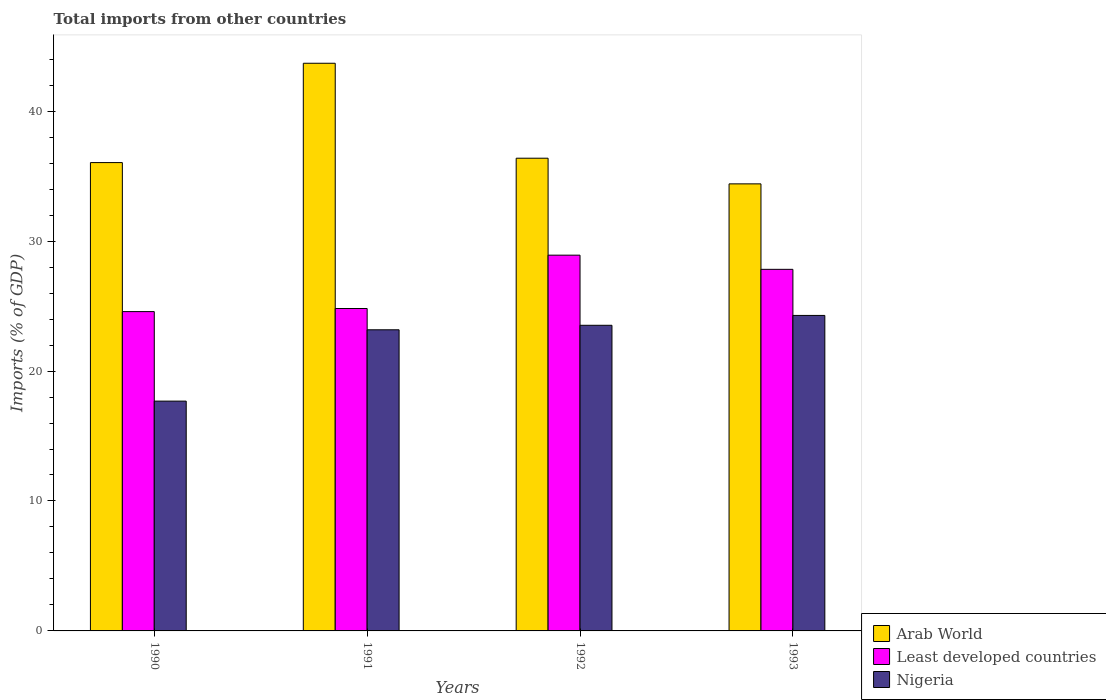How many groups of bars are there?
Offer a very short reply. 4. Are the number of bars on each tick of the X-axis equal?
Keep it short and to the point. Yes. What is the label of the 1st group of bars from the left?
Your answer should be compact. 1990. In how many cases, is the number of bars for a given year not equal to the number of legend labels?
Offer a terse response. 0. What is the total imports in Nigeria in 1993?
Your answer should be compact. 24.28. Across all years, what is the maximum total imports in Nigeria?
Make the answer very short. 24.28. Across all years, what is the minimum total imports in Least developed countries?
Your response must be concise. 24.57. In which year was the total imports in Nigeria maximum?
Give a very brief answer. 1993. What is the total total imports in Nigeria in the graph?
Provide a succinct answer. 88.66. What is the difference between the total imports in Arab World in 1991 and that in 1993?
Your response must be concise. 9.28. What is the difference between the total imports in Least developed countries in 1992 and the total imports in Arab World in 1991?
Your answer should be compact. -14.77. What is the average total imports in Arab World per year?
Give a very brief answer. 37.63. In the year 1990, what is the difference between the total imports in Arab World and total imports in Least developed countries?
Your response must be concise. 11.47. What is the ratio of the total imports in Arab World in 1991 to that in 1993?
Ensure brevity in your answer.  1.27. Is the difference between the total imports in Arab World in 1991 and 1992 greater than the difference between the total imports in Least developed countries in 1991 and 1992?
Give a very brief answer. Yes. What is the difference between the highest and the second highest total imports in Nigeria?
Provide a succinct answer. 0.76. What is the difference between the highest and the lowest total imports in Nigeria?
Offer a terse response. 6.59. What does the 1st bar from the left in 1991 represents?
Give a very brief answer. Arab World. What does the 1st bar from the right in 1990 represents?
Keep it short and to the point. Nigeria. Is it the case that in every year, the sum of the total imports in Least developed countries and total imports in Arab World is greater than the total imports in Nigeria?
Make the answer very short. Yes. How many bars are there?
Keep it short and to the point. 12. Are the values on the major ticks of Y-axis written in scientific E-notation?
Make the answer very short. No. Does the graph contain grids?
Keep it short and to the point. No. Where does the legend appear in the graph?
Offer a terse response. Bottom right. How many legend labels are there?
Offer a very short reply. 3. What is the title of the graph?
Your answer should be very brief. Total imports from other countries. Does "Uzbekistan" appear as one of the legend labels in the graph?
Give a very brief answer. No. What is the label or title of the Y-axis?
Your response must be concise. Imports (% of GDP). What is the Imports (% of GDP) in Arab World in 1990?
Your answer should be very brief. 36.04. What is the Imports (% of GDP) of Least developed countries in 1990?
Offer a terse response. 24.57. What is the Imports (% of GDP) of Nigeria in 1990?
Make the answer very short. 17.69. What is the Imports (% of GDP) of Arab World in 1991?
Provide a short and direct response. 43.69. What is the Imports (% of GDP) of Least developed countries in 1991?
Provide a succinct answer. 24.81. What is the Imports (% of GDP) in Nigeria in 1991?
Your response must be concise. 23.18. What is the Imports (% of GDP) of Arab World in 1992?
Give a very brief answer. 36.38. What is the Imports (% of GDP) in Least developed countries in 1992?
Keep it short and to the point. 28.92. What is the Imports (% of GDP) of Nigeria in 1992?
Provide a short and direct response. 23.52. What is the Imports (% of GDP) of Arab World in 1993?
Make the answer very short. 34.41. What is the Imports (% of GDP) of Least developed countries in 1993?
Make the answer very short. 27.83. What is the Imports (% of GDP) in Nigeria in 1993?
Keep it short and to the point. 24.28. Across all years, what is the maximum Imports (% of GDP) of Arab World?
Provide a succinct answer. 43.69. Across all years, what is the maximum Imports (% of GDP) of Least developed countries?
Offer a terse response. 28.92. Across all years, what is the maximum Imports (% of GDP) of Nigeria?
Your response must be concise. 24.28. Across all years, what is the minimum Imports (% of GDP) in Arab World?
Provide a succinct answer. 34.41. Across all years, what is the minimum Imports (% of GDP) of Least developed countries?
Your answer should be very brief. 24.57. Across all years, what is the minimum Imports (% of GDP) in Nigeria?
Your answer should be very brief. 17.69. What is the total Imports (% of GDP) in Arab World in the graph?
Your answer should be compact. 150.52. What is the total Imports (% of GDP) in Least developed countries in the graph?
Provide a succinct answer. 106.13. What is the total Imports (% of GDP) of Nigeria in the graph?
Offer a terse response. 88.66. What is the difference between the Imports (% of GDP) of Arab World in 1990 and that in 1991?
Make the answer very short. -7.64. What is the difference between the Imports (% of GDP) in Least developed countries in 1990 and that in 1991?
Keep it short and to the point. -0.24. What is the difference between the Imports (% of GDP) of Nigeria in 1990 and that in 1991?
Offer a terse response. -5.49. What is the difference between the Imports (% of GDP) of Arab World in 1990 and that in 1992?
Provide a short and direct response. -0.34. What is the difference between the Imports (% of GDP) in Least developed countries in 1990 and that in 1992?
Your answer should be very brief. -4.34. What is the difference between the Imports (% of GDP) in Nigeria in 1990 and that in 1992?
Make the answer very short. -5.84. What is the difference between the Imports (% of GDP) in Arab World in 1990 and that in 1993?
Make the answer very short. 1.64. What is the difference between the Imports (% of GDP) of Least developed countries in 1990 and that in 1993?
Ensure brevity in your answer.  -3.25. What is the difference between the Imports (% of GDP) in Nigeria in 1990 and that in 1993?
Provide a succinct answer. -6.59. What is the difference between the Imports (% of GDP) of Arab World in 1991 and that in 1992?
Keep it short and to the point. 7.31. What is the difference between the Imports (% of GDP) in Least developed countries in 1991 and that in 1992?
Offer a terse response. -4.11. What is the difference between the Imports (% of GDP) of Nigeria in 1991 and that in 1992?
Ensure brevity in your answer.  -0.35. What is the difference between the Imports (% of GDP) of Arab World in 1991 and that in 1993?
Keep it short and to the point. 9.28. What is the difference between the Imports (% of GDP) in Least developed countries in 1991 and that in 1993?
Keep it short and to the point. -3.02. What is the difference between the Imports (% of GDP) in Nigeria in 1991 and that in 1993?
Your answer should be compact. -1.1. What is the difference between the Imports (% of GDP) of Arab World in 1992 and that in 1993?
Your answer should be compact. 1.97. What is the difference between the Imports (% of GDP) in Least developed countries in 1992 and that in 1993?
Provide a succinct answer. 1.09. What is the difference between the Imports (% of GDP) of Nigeria in 1992 and that in 1993?
Your response must be concise. -0.76. What is the difference between the Imports (% of GDP) in Arab World in 1990 and the Imports (% of GDP) in Least developed countries in 1991?
Keep it short and to the point. 11.23. What is the difference between the Imports (% of GDP) of Arab World in 1990 and the Imports (% of GDP) of Nigeria in 1991?
Make the answer very short. 12.87. What is the difference between the Imports (% of GDP) of Least developed countries in 1990 and the Imports (% of GDP) of Nigeria in 1991?
Your answer should be compact. 1.4. What is the difference between the Imports (% of GDP) of Arab World in 1990 and the Imports (% of GDP) of Least developed countries in 1992?
Your response must be concise. 7.13. What is the difference between the Imports (% of GDP) in Arab World in 1990 and the Imports (% of GDP) in Nigeria in 1992?
Keep it short and to the point. 12.52. What is the difference between the Imports (% of GDP) of Least developed countries in 1990 and the Imports (% of GDP) of Nigeria in 1992?
Give a very brief answer. 1.05. What is the difference between the Imports (% of GDP) of Arab World in 1990 and the Imports (% of GDP) of Least developed countries in 1993?
Your answer should be compact. 8.22. What is the difference between the Imports (% of GDP) in Arab World in 1990 and the Imports (% of GDP) in Nigeria in 1993?
Make the answer very short. 11.76. What is the difference between the Imports (% of GDP) of Least developed countries in 1990 and the Imports (% of GDP) of Nigeria in 1993?
Your answer should be very brief. 0.29. What is the difference between the Imports (% of GDP) of Arab World in 1991 and the Imports (% of GDP) of Least developed countries in 1992?
Your answer should be compact. 14.77. What is the difference between the Imports (% of GDP) in Arab World in 1991 and the Imports (% of GDP) in Nigeria in 1992?
Provide a short and direct response. 20.17. What is the difference between the Imports (% of GDP) of Least developed countries in 1991 and the Imports (% of GDP) of Nigeria in 1992?
Ensure brevity in your answer.  1.29. What is the difference between the Imports (% of GDP) in Arab World in 1991 and the Imports (% of GDP) in Least developed countries in 1993?
Your response must be concise. 15.86. What is the difference between the Imports (% of GDP) in Arab World in 1991 and the Imports (% of GDP) in Nigeria in 1993?
Offer a very short reply. 19.41. What is the difference between the Imports (% of GDP) in Least developed countries in 1991 and the Imports (% of GDP) in Nigeria in 1993?
Ensure brevity in your answer.  0.53. What is the difference between the Imports (% of GDP) of Arab World in 1992 and the Imports (% of GDP) of Least developed countries in 1993?
Offer a terse response. 8.55. What is the difference between the Imports (% of GDP) of Arab World in 1992 and the Imports (% of GDP) of Nigeria in 1993?
Provide a short and direct response. 12.1. What is the difference between the Imports (% of GDP) of Least developed countries in 1992 and the Imports (% of GDP) of Nigeria in 1993?
Provide a short and direct response. 4.64. What is the average Imports (% of GDP) in Arab World per year?
Give a very brief answer. 37.63. What is the average Imports (% of GDP) of Least developed countries per year?
Offer a very short reply. 26.53. What is the average Imports (% of GDP) in Nigeria per year?
Your response must be concise. 22.17. In the year 1990, what is the difference between the Imports (% of GDP) of Arab World and Imports (% of GDP) of Least developed countries?
Your response must be concise. 11.47. In the year 1990, what is the difference between the Imports (% of GDP) of Arab World and Imports (% of GDP) of Nigeria?
Your answer should be very brief. 18.36. In the year 1990, what is the difference between the Imports (% of GDP) in Least developed countries and Imports (% of GDP) in Nigeria?
Your answer should be compact. 6.89. In the year 1991, what is the difference between the Imports (% of GDP) in Arab World and Imports (% of GDP) in Least developed countries?
Your response must be concise. 18.87. In the year 1991, what is the difference between the Imports (% of GDP) of Arab World and Imports (% of GDP) of Nigeria?
Provide a succinct answer. 20.51. In the year 1991, what is the difference between the Imports (% of GDP) in Least developed countries and Imports (% of GDP) in Nigeria?
Ensure brevity in your answer.  1.64. In the year 1992, what is the difference between the Imports (% of GDP) in Arab World and Imports (% of GDP) in Least developed countries?
Your answer should be very brief. 7.46. In the year 1992, what is the difference between the Imports (% of GDP) of Arab World and Imports (% of GDP) of Nigeria?
Offer a terse response. 12.86. In the year 1992, what is the difference between the Imports (% of GDP) in Least developed countries and Imports (% of GDP) in Nigeria?
Provide a succinct answer. 5.4. In the year 1993, what is the difference between the Imports (% of GDP) in Arab World and Imports (% of GDP) in Least developed countries?
Your answer should be compact. 6.58. In the year 1993, what is the difference between the Imports (% of GDP) of Arab World and Imports (% of GDP) of Nigeria?
Provide a short and direct response. 10.13. In the year 1993, what is the difference between the Imports (% of GDP) in Least developed countries and Imports (% of GDP) in Nigeria?
Your answer should be compact. 3.55. What is the ratio of the Imports (% of GDP) of Arab World in 1990 to that in 1991?
Your answer should be compact. 0.82. What is the ratio of the Imports (% of GDP) of Least developed countries in 1990 to that in 1991?
Your response must be concise. 0.99. What is the ratio of the Imports (% of GDP) of Nigeria in 1990 to that in 1991?
Provide a short and direct response. 0.76. What is the ratio of the Imports (% of GDP) of Least developed countries in 1990 to that in 1992?
Keep it short and to the point. 0.85. What is the ratio of the Imports (% of GDP) of Nigeria in 1990 to that in 1992?
Your answer should be compact. 0.75. What is the ratio of the Imports (% of GDP) of Arab World in 1990 to that in 1993?
Keep it short and to the point. 1.05. What is the ratio of the Imports (% of GDP) of Least developed countries in 1990 to that in 1993?
Ensure brevity in your answer.  0.88. What is the ratio of the Imports (% of GDP) in Nigeria in 1990 to that in 1993?
Offer a very short reply. 0.73. What is the ratio of the Imports (% of GDP) of Arab World in 1991 to that in 1992?
Offer a terse response. 1.2. What is the ratio of the Imports (% of GDP) in Least developed countries in 1991 to that in 1992?
Your answer should be very brief. 0.86. What is the ratio of the Imports (% of GDP) of Nigeria in 1991 to that in 1992?
Provide a succinct answer. 0.99. What is the ratio of the Imports (% of GDP) of Arab World in 1991 to that in 1993?
Your answer should be very brief. 1.27. What is the ratio of the Imports (% of GDP) in Least developed countries in 1991 to that in 1993?
Your answer should be compact. 0.89. What is the ratio of the Imports (% of GDP) in Nigeria in 1991 to that in 1993?
Your response must be concise. 0.95. What is the ratio of the Imports (% of GDP) in Arab World in 1992 to that in 1993?
Give a very brief answer. 1.06. What is the ratio of the Imports (% of GDP) in Least developed countries in 1992 to that in 1993?
Keep it short and to the point. 1.04. What is the ratio of the Imports (% of GDP) of Nigeria in 1992 to that in 1993?
Your answer should be very brief. 0.97. What is the difference between the highest and the second highest Imports (% of GDP) in Arab World?
Provide a succinct answer. 7.31. What is the difference between the highest and the second highest Imports (% of GDP) in Least developed countries?
Your answer should be compact. 1.09. What is the difference between the highest and the second highest Imports (% of GDP) of Nigeria?
Provide a succinct answer. 0.76. What is the difference between the highest and the lowest Imports (% of GDP) in Arab World?
Your answer should be compact. 9.28. What is the difference between the highest and the lowest Imports (% of GDP) of Least developed countries?
Your answer should be compact. 4.34. What is the difference between the highest and the lowest Imports (% of GDP) of Nigeria?
Keep it short and to the point. 6.59. 